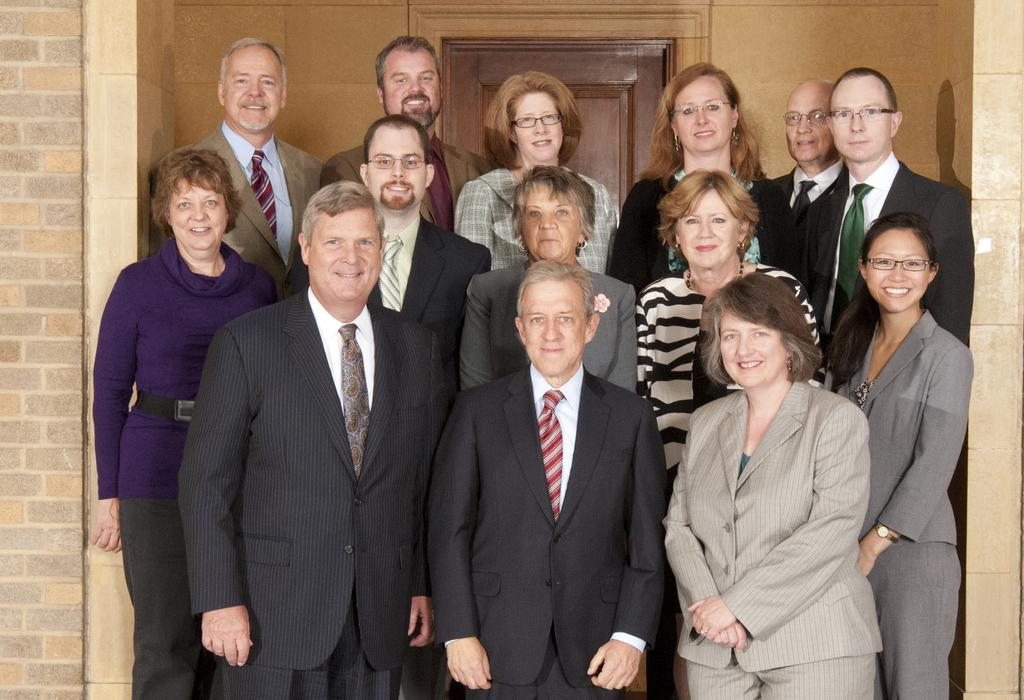How many people are in the image? There are persons standing in the image. What is the facial expression of the persons in the image? The persons are smiling. What can be seen in the background of the image? There is a wall and a door in the background of the image. What type of goldfish can be seen swimming near the door in the image? There is no goldfish present in the image; it only features persons standing and a wall and door in the background. 